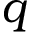<formula> <loc_0><loc_0><loc_500><loc_500>q</formula> 